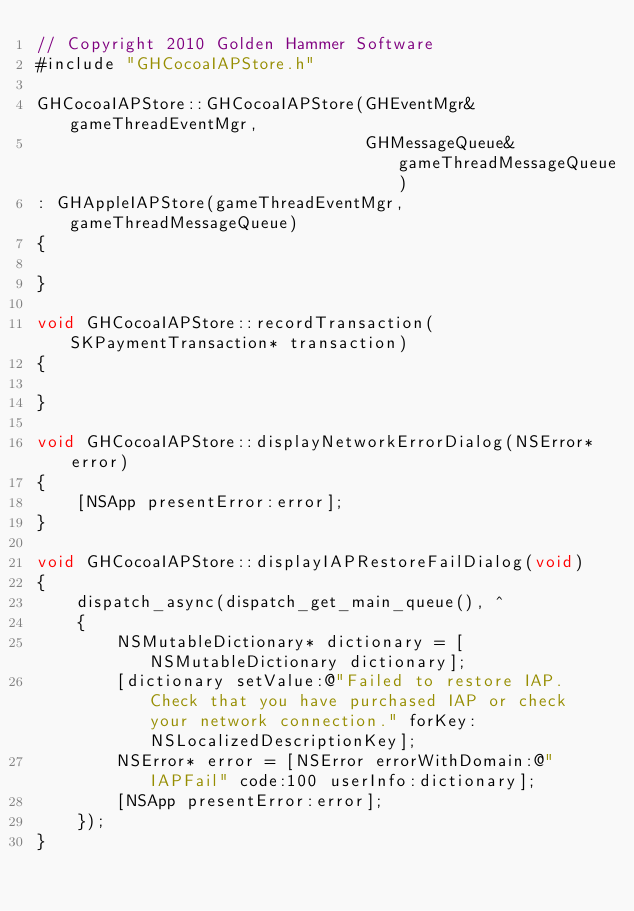Convert code to text. <code><loc_0><loc_0><loc_500><loc_500><_ObjectiveC_>// Copyright 2010 Golden Hammer Software
#include "GHCocoaIAPStore.h"

GHCocoaIAPStore::GHCocoaIAPStore(GHEventMgr& gameThreadEventMgr,
                                 GHMessageQueue& gameThreadMessageQueue)
: GHAppleIAPStore(gameThreadEventMgr, gameThreadMessageQueue)
{
    
}

void GHCocoaIAPStore::recordTransaction(SKPaymentTransaction* transaction)
{
    
}

void GHCocoaIAPStore::displayNetworkErrorDialog(NSError* error)
{
    [NSApp presentError:error];
}

void GHCocoaIAPStore::displayIAPRestoreFailDialog(void)
{
    dispatch_async(dispatch_get_main_queue(), ^
    {
        NSMutableDictionary* dictionary = [NSMutableDictionary dictionary];
        [dictionary setValue:@"Failed to restore IAP. Check that you have purchased IAP or check your network connection." forKey:NSLocalizedDescriptionKey];
        NSError* error = [NSError errorWithDomain:@"IAPFail" code:100 userInfo:dictionary];
        [NSApp presentError:error];
    });
}
</code> 